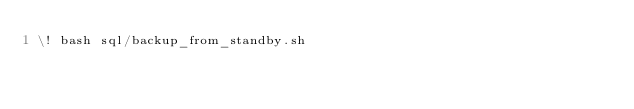Convert code to text. <code><loc_0><loc_0><loc_500><loc_500><_SQL_>\! bash sql/backup_from_standby.sh

</code> 